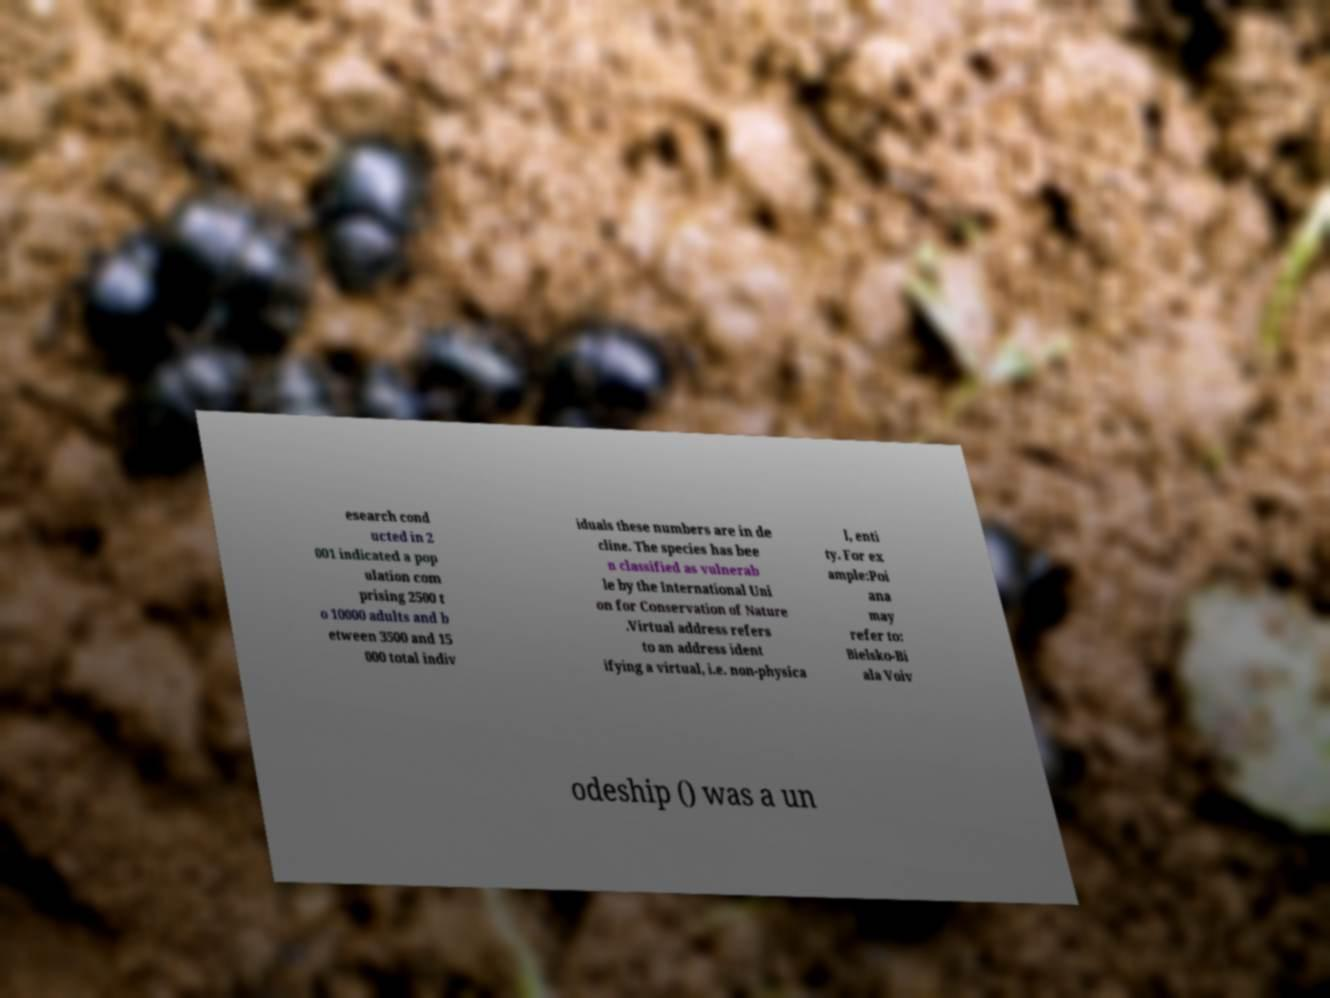Can you accurately transcribe the text from the provided image for me? esearch cond ucted in 2 001 indicated a pop ulation com prising 2500 t o 10000 adults and b etween 3500 and 15 000 total indiv iduals these numbers are in de cline. The species has bee n classified as vulnerab le by the International Uni on for Conservation of Nature .Virtual address refers to an address ident ifying a virtual, i.e. non-physica l, enti ty. For ex ample:Poi ana may refer to: Bielsko-Bi ala Voiv odeship () was a un 